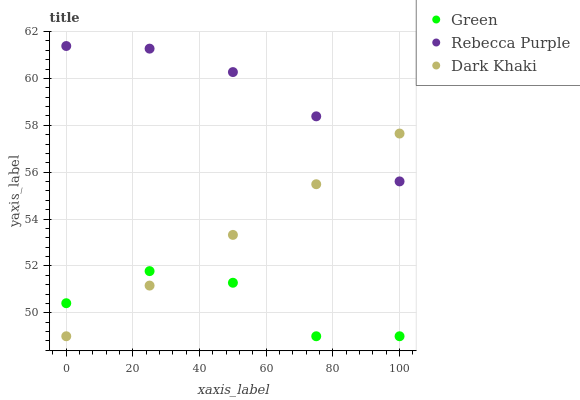Does Green have the minimum area under the curve?
Answer yes or no. Yes. Does Rebecca Purple have the maximum area under the curve?
Answer yes or no. Yes. Does Rebecca Purple have the minimum area under the curve?
Answer yes or no. No. Does Green have the maximum area under the curve?
Answer yes or no. No. Is Dark Khaki the smoothest?
Answer yes or no. Yes. Is Green the roughest?
Answer yes or no. Yes. Is Rebecca Purple the smoothest?
Answer yes or no. No. Is Rebecca Purple the roughest?
Answer yes or no. No. Does Dark Khaki have the lowest value?
Answer yes or no. Yes. Does Rebecca Purple have the lowest value?
Answer yes or no. No. Does Rebecca Purple have the highest value?
Answer yes or no. Yes. Does Green have the highest value?
Answer yes or no. No. Is Green less than Rebecca Purple?
Answer yes or no. Yes. Is Rebecca Purple greater than Green?
Answer yes or no. Yes. Does Green intersect Dark Khaki?
Answer yes or no. Yes. Is Green less than Dark Khaki?
Answer yes or no. No. Is Green greater than Dark Khaki?
Answer yes or no. No. Does Green intersect Rebecca Purple?
Answer yes or no. No. 